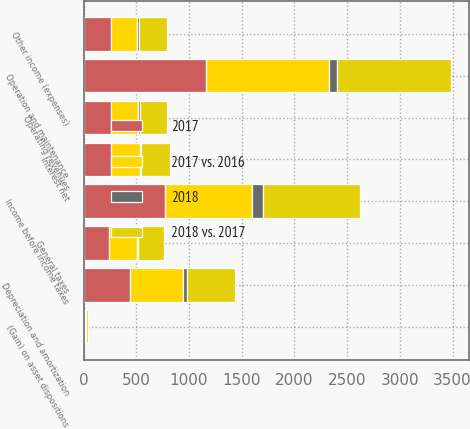Convert chart to OTSL. <chart><loc_0><loc_0><loc_500><loc_500><stacked_bar_chart><ecel><fcel>Operating revenues<fcel>Operation and maintenance<fcel>Depreciation and amortization<fcel>General taxes<fcel>(Gain) on asset dispositions<fcel>Interest net<fcel>Other income (expenses)<fcel>Income before income taxes<nl><fcel>2017 vs. 2016<fcel>256<fcel>1159<fcel>500<fcel>261<fcel>7<fcel>280<fcel>247<fcel>826<nl><fcel>2018 vs. 2017<fcel>256<fcel>1076<fcel>462<fcel>244<fcel>16<fcel>268<fcel>266<fcel>925<nl><fcel>2017<fcel>256<fcel>1165<fcel>440<fcel>242<fcel>7<fcel>256<fcel>257<fcel>775<nl><fcel>2018<fcel>26<fcel>83<fcel>38<fcel>17<fcel>9<fcel>12<fcel>19<fcel>99<nl></chart> 